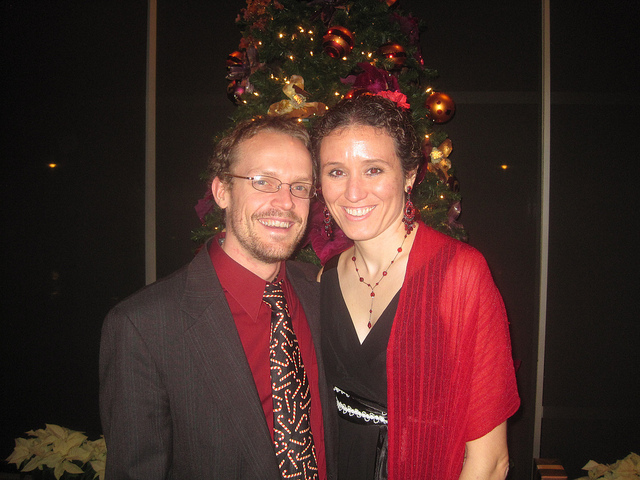<image>What is the woman with the red coat holding in her left hand? It is unknown what the woman with the red coat is holding in her left hand. It could be a cell phone, a purse, or potentially nothing. What is the woman with the red coat holding in her left hand? I don't know what the woman with the red coat is holding in her left hand. It can be anything from her dress to a cell phone or a purse. 